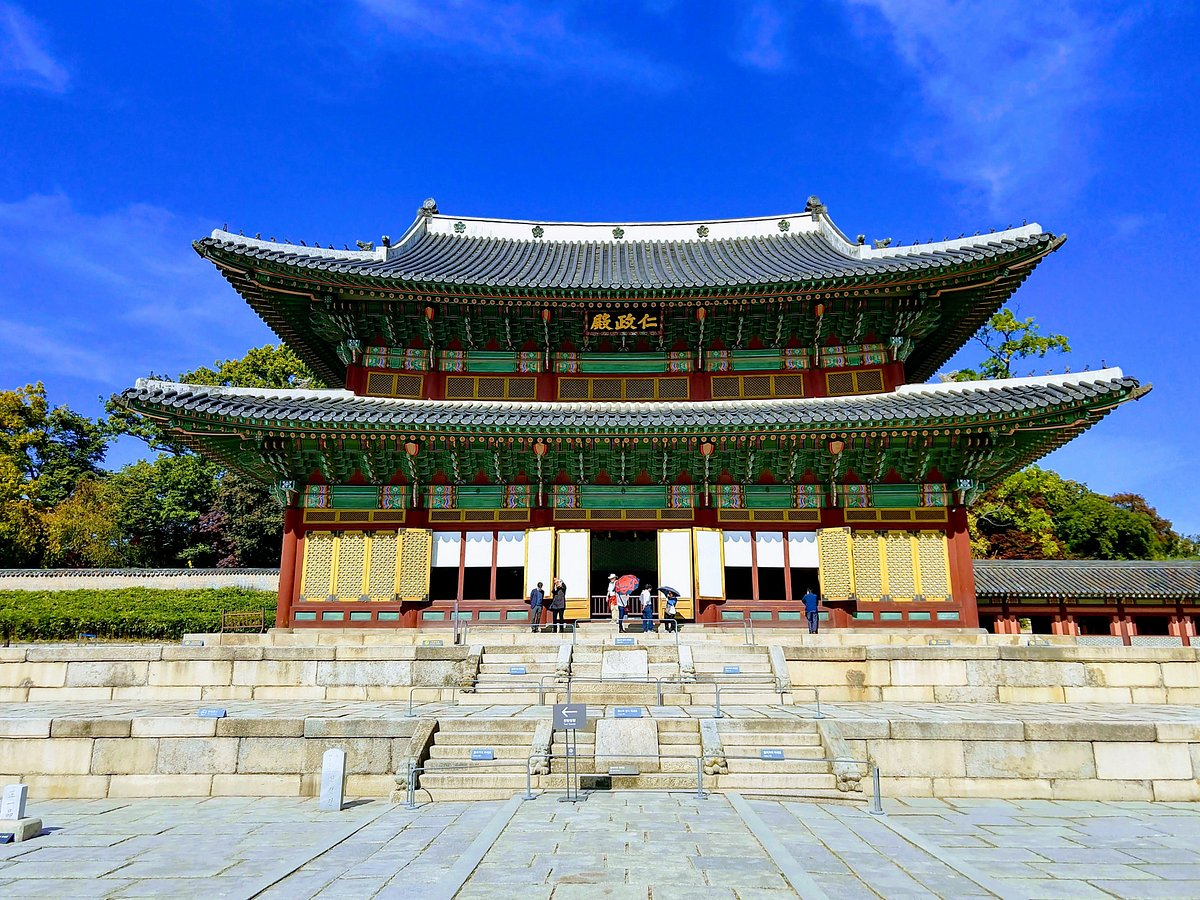Can you elaborate on the elements of the picture provided? The image provides a striking view of the Changdeokgung Palace Complex in Seoul, South Korea, known for its harmonious blend of natural landscape and architectural elements. The palace displays a quintessential example of traditional Korean architecture with its intricate detailing, such as the vibrant green tiles and the delicate use of red and gold accents that enhance the wooden structures under a clear blue sky. Viewed from a low angle, the photograph emphasizes the palace’s imposing structure. Visible are the stairs that lead up to the central hall, inviting exploration into a site rich with history dating back to the Joseon Dynasty. The image also captures the dynamic between human visitors and this historical site, showing people at different points of engagement: some ascending the stairs, others taking in the view. The lush greenery surrounding the palace plays into the traditional Korean aesthetic of natural beauty and adds a calming element to the architectural grandeur. This palace not only serves as a cultural heritage site but also exemplifies traditional East Asian palace architecture, adapted to the complementary relationship between the built environment and the natural world. 